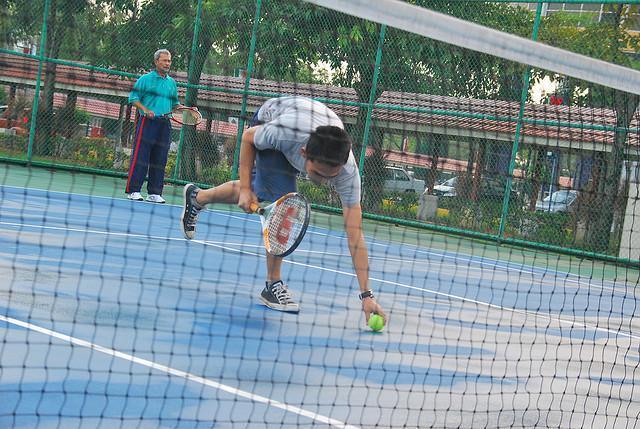How many people can you see?
Give a very brief answer. 2. 